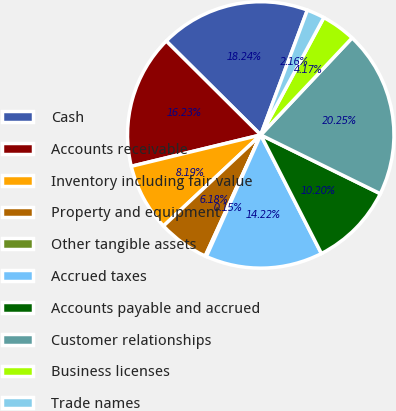Convert chart. <chart><loc_0><loc_0><loc_500><loc_500><pie_chart><fcel>Cash<fcel>Accounts receivable<fcel>Inventory including fair value<fcel>Property and equipment<fcel>Other tangible assets<fcel>Accrued taxes<fcel>Accounts payable and accrued<fcel>Customer relationships<fcel>Business licenses<fcel>Trade names<nl><fcel>18.24%<fcel>16.23%<fcel>8.19%<fcel>6.18%<fcel>0.15%<fcel>14.22%<fcel>10.2%<fcel>20.25%<fcel>4.17%<fcel>2.16%<nl></chart> 